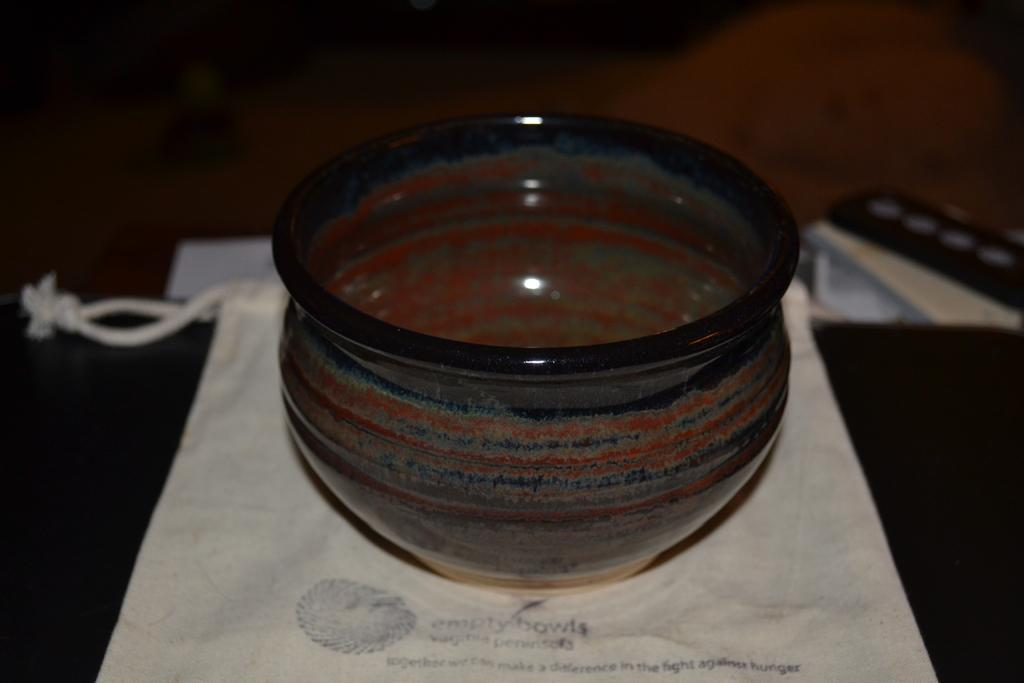What object can be seen in the image that is used for holding or containing items? There is a vessel in the image that is used for holding or containing items. Where is the vessel located in the image? The vessel is placed on a table in the image. What other object can be seen in the image that is also placed on a table? There is a cloth in the image that is placed on a table. What type of unit is being used to measure the distance between the vessel and the cloth in the image? There is no unit or measurement of distance mentioned or depicted in the image. 